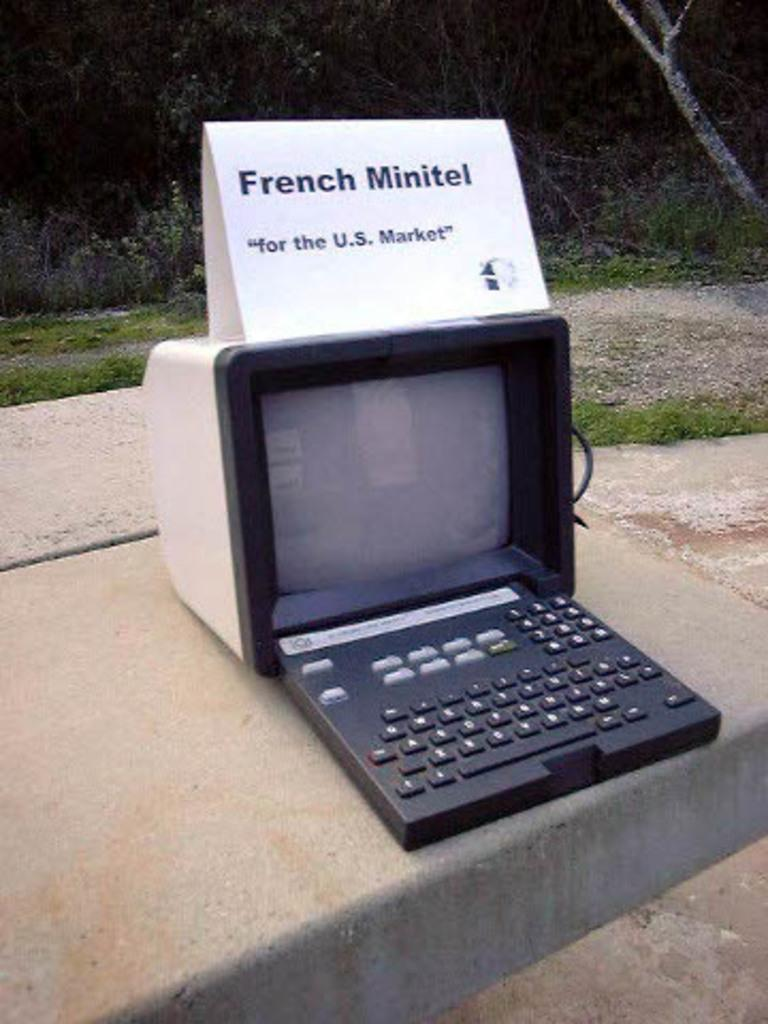What is the main object visible on the computer in the image? There is a computer screen in the image. What is used to input information into the computer? There is a keyboard in the image. What information is displayed on the computer? The name plate on the computer provides information, but we cannot determine its content from the image. What type of natural environment is visible in the background of the image? Trees, plants, and grass are visible in the background of the image. What rule is being enforced by the prison guard in the image? There is no prison or guard present in the image; it features a computer with a screen, keyboard, and name plate, along with a natural background. 